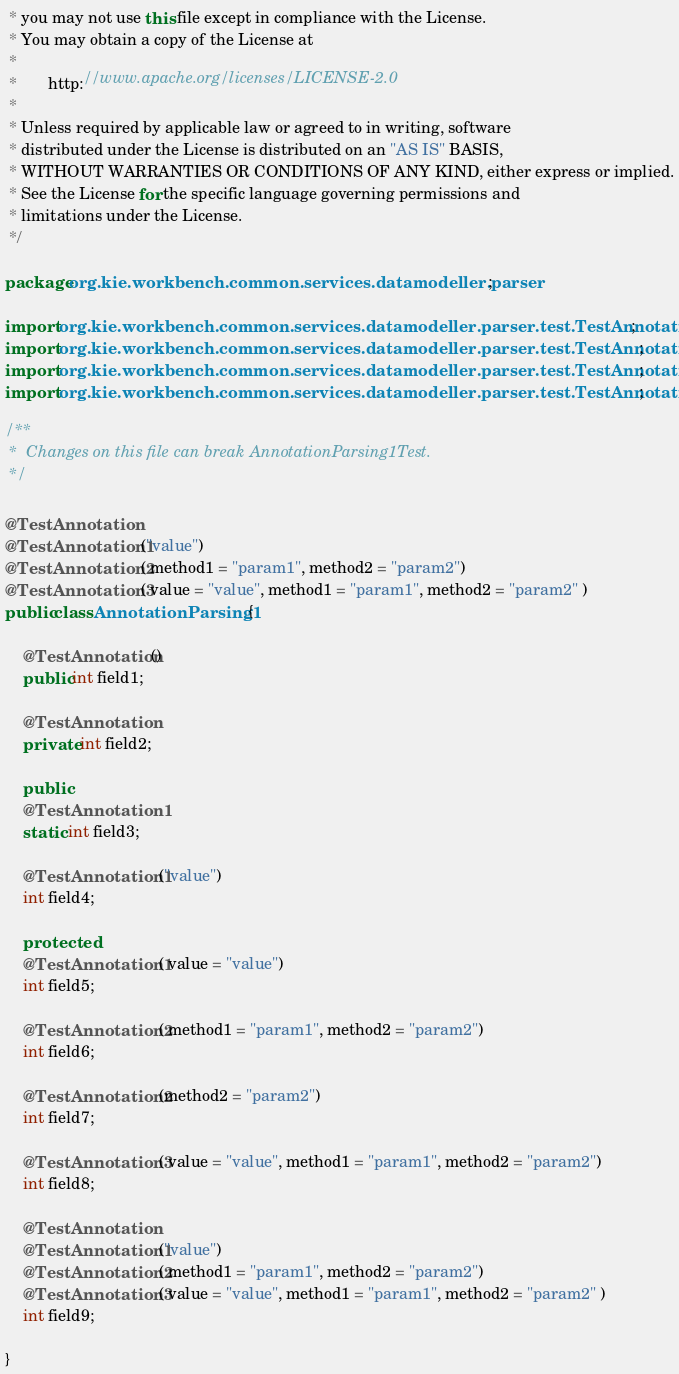Convert code to text. <code><loc_0><loc_0><loc_500><loc_500><_Java_> * you may not use this file except in compliance with the License.
 * You may obtain a copy of the License at
 *
 *       http://www.apache.org/licenses/LICENSE-2.0
 *
 * Unless required by applicable law or agreed to in writing, software
 * distributed under the License is distributed on an "AS IS" BASIS,
 * WITHOUT WARRANTIES OR CONDITIONS OF ANY KIND, either express or implied.
 * See the License for the specific language governing permissions and
 * limitations under the License.
 */

package org.kie.workbench.common.services.datamodeller.parser;

import org.kie.workbench.common.services.datamodeller.parser.test.TestAnnotation;
import org.kie.workbench.common.services.datamodeller.parser.test.TestAnnotation1;
import org.kie.workbench.common.services.datamodeller.parser.test.TestAnnotation2;
import org.kie.workbench.common.services.datamodeller.parser.test.TestAnnotation3;

/**
 *  Changes on this file can break AnnotationParsing1Test.
 */

@TestAnnotation
@TestAnnotation1("value")
@TestAnnotation2( method1 = "param1", method2 = "param2")
@TestAnnotation3( value = "value", method1 = "param1", method2 = "param2" )
public class AnnotationParsing1 {

    @TestAnnotation()
    public int field1;

    @TestAnnotation
    private int field2;

    public
    @TestAnnotation1
    static int field3;

    @TestAnnotation1("value")
    int field4;

    protected
    @TestAnnotation1( value = "value")
    int field5;

    @TestAnnotation2( method1 = "param1", method2 = "param2")
    int field6;

    @TestAnnotation2(method2 = "param2")
    int field7;

    @TestAnnotation3( value = "value", method1 = "param1", method2 = "param2")
    int field8;

    @TestAnnotation
    @TestAnnotation1("value")
    @TestAnnotation2( method1 = "param1", method2 = "param2")
    @TestAnnotation3( value = "value", method1 = "param1", method2 = "param2" )
    int field9;

}
</code> 